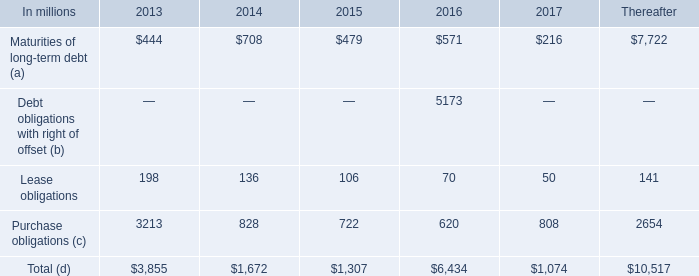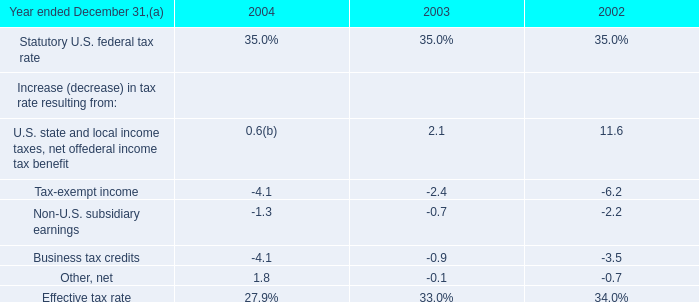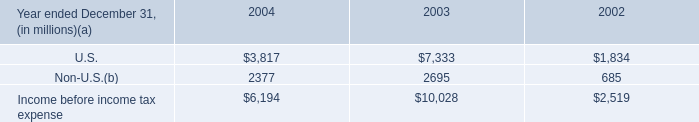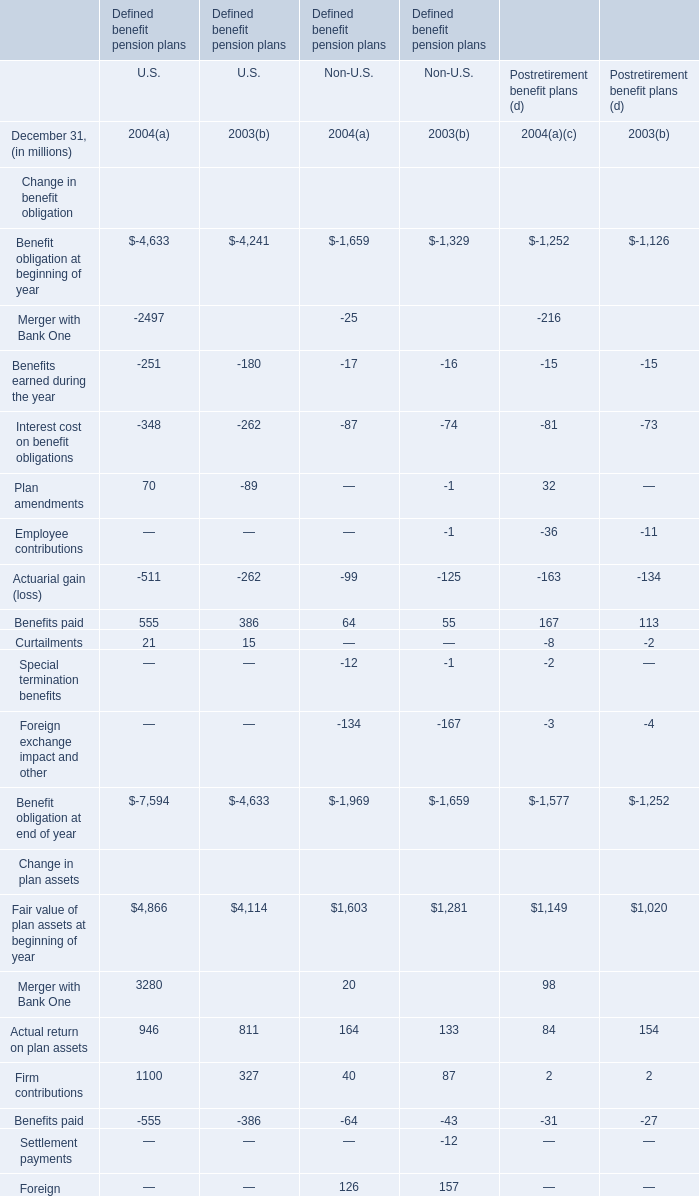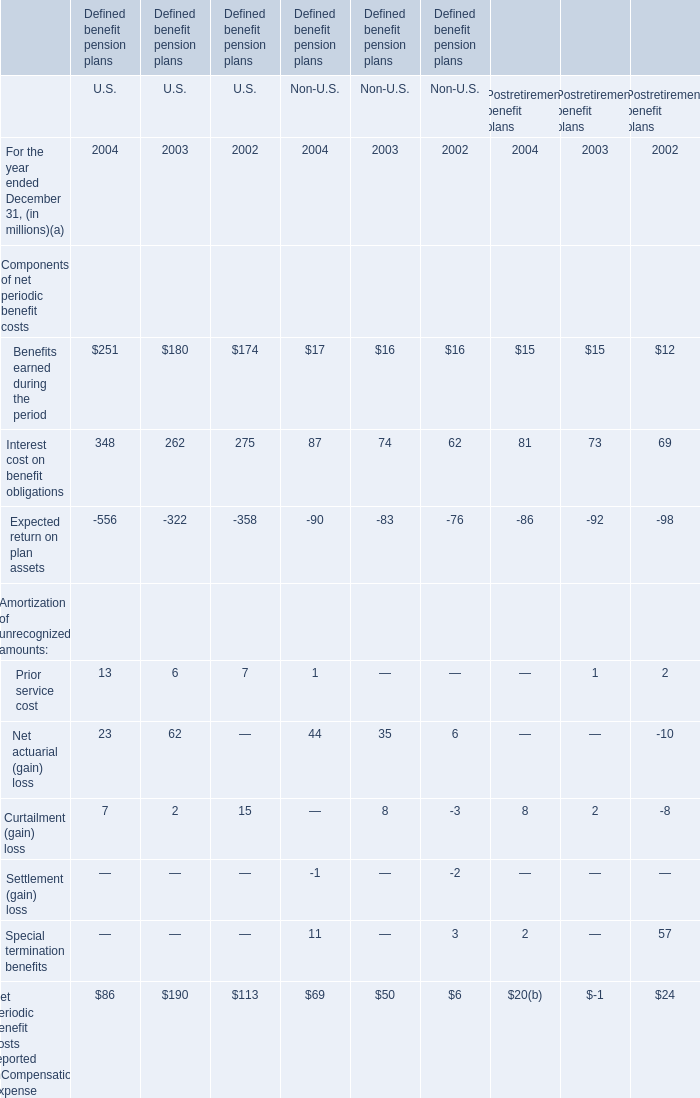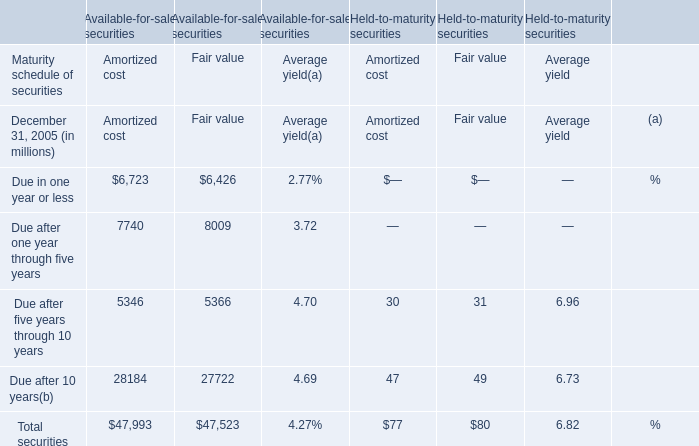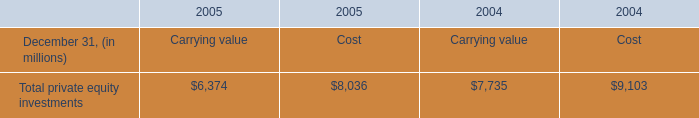In what year is Net periodic benefit costs reported in Compensation expense under Defined benefit pension plans for Non-U.S. the most? 
Answer: 2004. 